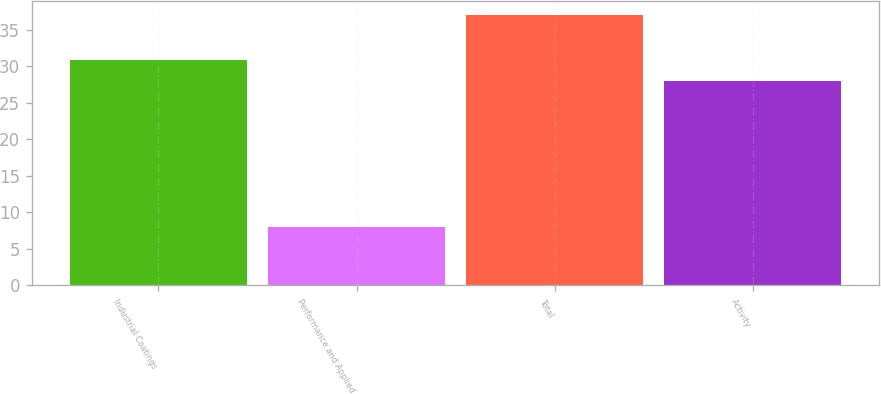Convert chart. <chart><loc_0><loc_0><loc_500><loc_500><bar_chart><fcel>Industrial Coatings<fcel>Performance and Applied<fcel>Total<fcel>Activity<nl><fcel>30.9<fcel>8<fcel>37<fcel>28<nl></chart> 